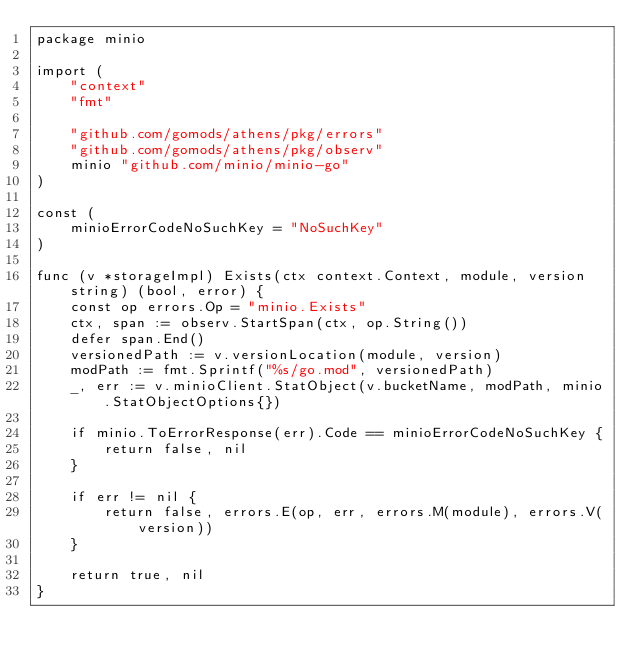Convert code to text. <code><loc_0><loc_0><loc_500><loc_500><_Go_>package minio

import (
	"context"
	"fmt"

	"github.com/gomods/athens/pkg/errors"
	"github.com/gomods/athens/pkg/observ"
	minio "github.com/minio/minio-go"
)

const (
	minioErrorCodeNoSuchKey = "NoSuchKey"
)

func (v *storageImpl) Exists(ctx context.Context, module, version string) (bool, error) {
	const op errors.Op = "minio.Exists"
	ctx, span := observ.StartSpan(ctx, op.String())
	defer span.End()
	versionedPath := v.versionLocation(module, version)
	modPath := fmt.Sprintf("%s/go.mod", versionedPath)
	_, err := v.minioClient.StatObject(v.bucketName, modPath, minio.StatObjectOptions{})

	if minio.ToErrorResponse(err).Code == minioErrorCodeNoSuchKey {
		return false, nil
	}

	if err != nil {
		return false, errors.E(op, err, errors.M(module), errors.V(version))
	}

	return true, nil
}
</code> 